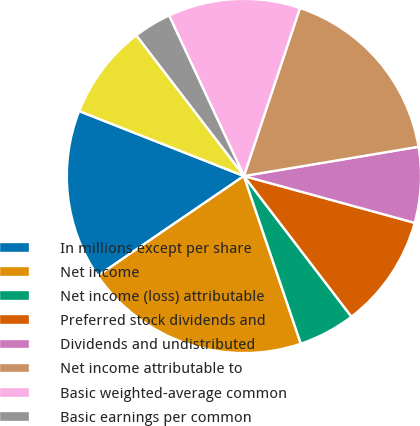<chart> <loc_0><loc_0><loc_500><loc_500><pie_chart><fcel>In millions except per share<fcel>Net income<fcel>Net income (loss) attributable<fcel>Preferred stock dividends and<fcel>Dividends and undistributed<fcel>Net income attributable to<fcel>Basic weighted-average common<fcel>Basic earnings per common<fcel>Less Impact of BlackRock<nl><fcel>15.51%<fcel>20.67%<fcel>5.18%<fcel>10.35%<fcel>6.9%<fcel>17.23%<fcel>12.07%<fcel>3.46%<fcel>8.62%<nl></chart> 